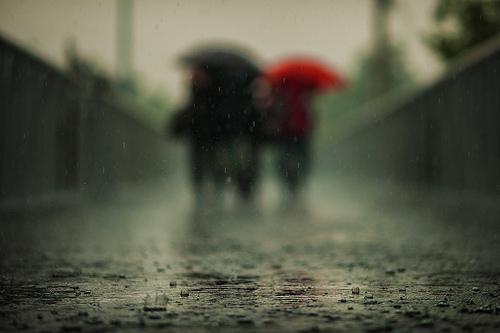How many red umbrellas are in the photo?
Give a very brief answer. 1. How many black umbrellas are in the scene?
Give a very brief answer. 1. 